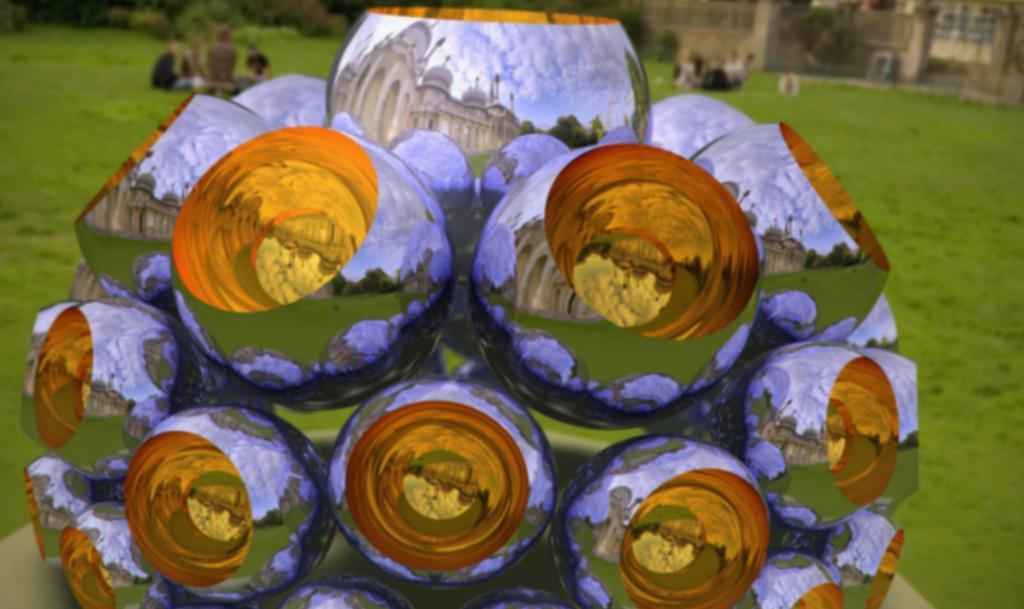How would you summarize this image in a sentence or two? In this image in front there are decorative objects. In the background of the image there are few people sitting on the grass. There are buildings and plants. 